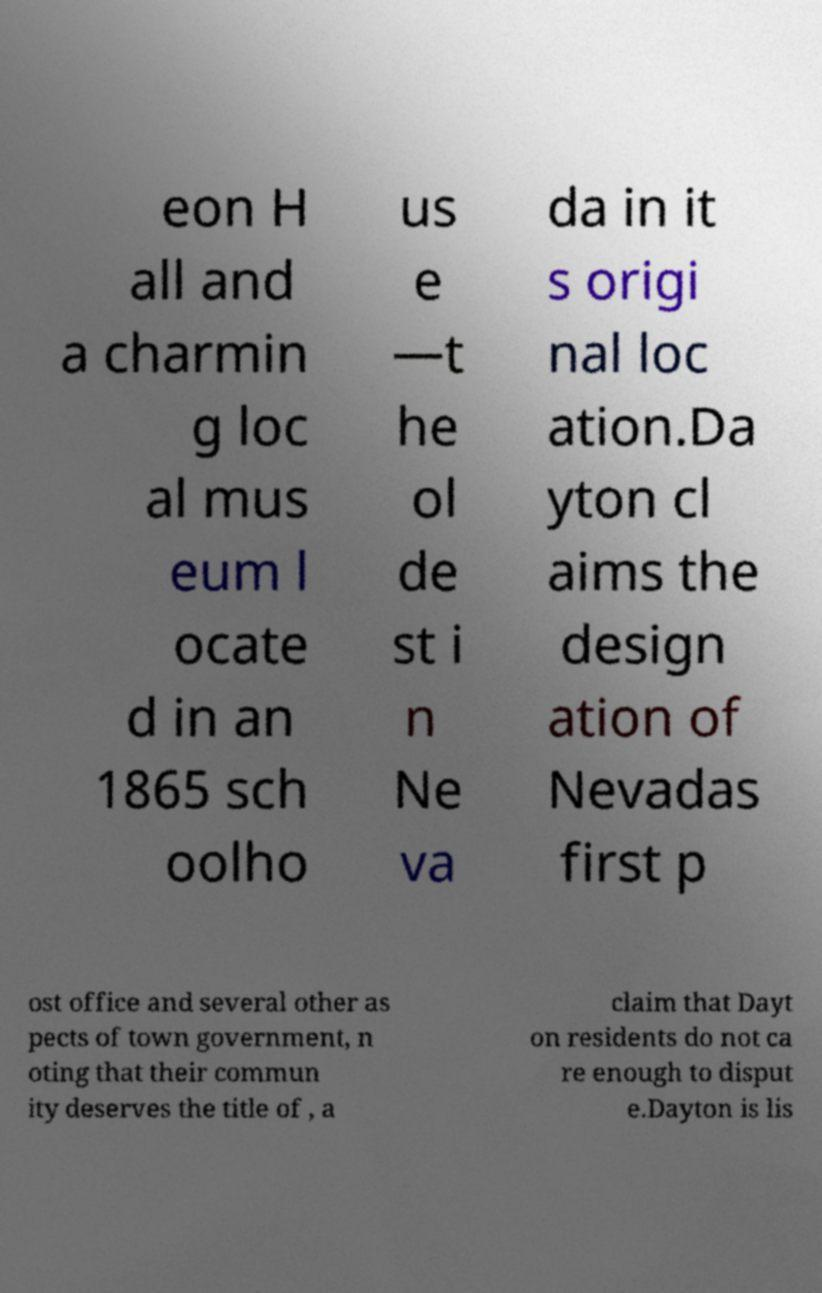Can you read and provide the text displayed in the image?This photo seems to have some interesting text. Can you extract and type it out for me? eon H all and a charmin g loc al mus eum l ocate d in an 1865 sch oolho us e —t he ol de st i n Ne va da in it s origi nal loc ation.Da yton cl aims the design ation of Nevadas first p ost office and several other as pects of town government, n oting that their commun ity deserves the title of , a claim that Dayt on residents do not ca re enough to disput e.Dayton is lis 